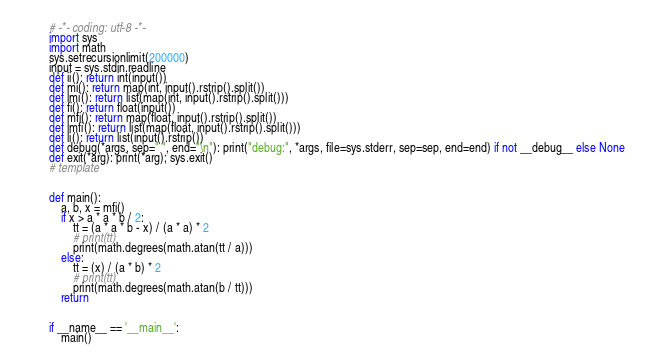Convert code to text. <code><loc_0><loc_0><loc_500><loc_500><_Python_># -*- coding: utf-8 -*-
import sys
import math
sys.setrecursionlimit(200000)
input = sys.stdin.readline
def ii(): return int(input())
def mi(): return map(int, input().rstrip().split())
def lmi(): return list(map(int, input().rstrip().split()))
def fi(): return float(input())
def mfi(): return map(float, input().rstrip().split())
def lmfi(): return list(map(float, input().rstrip().split()))
def li(): return list(input().rstrip())
def debug(*args, sep=" ", end="\n"): print("debug:", *args, file=sys.stderr, sep=sep, end=end) if not __debug__ else None
def exit(*arg): print(*arg); sys.exit()
# template


def main():
    a, b, x = mfi()
    if x > a * a * b / 2:
        tt = (a * a * b - x) / (a * a) * 2
        # print(tt)
        print(math.degrees(math.atan(tt / a)))
    else:
        tt = (x) / (a * b) * 2
        # print(tt)
        print(math.degrees(math.atan(b / tt)))
    return


if __name__ == '__main__':
    main()
</code> 